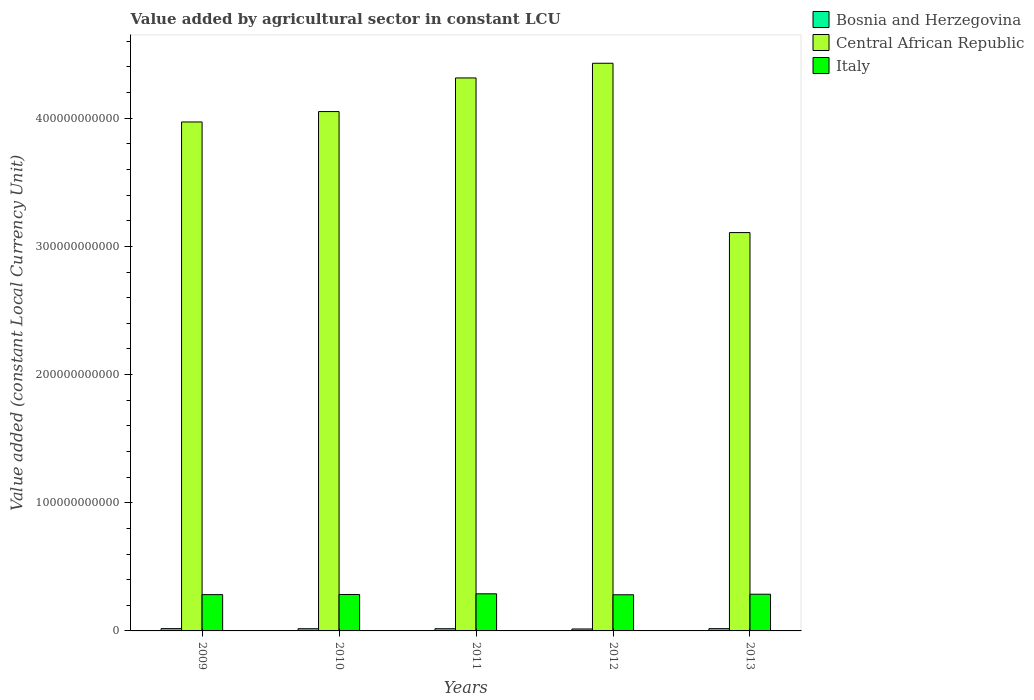How many groups of bars are there?
Your answer should be compact. 5. Are the number of bars per tick equal to the number of legend labels?
Your answer should be compact. Yes. Are the number of bars on each tick of the X-axis equal?
Provide a short and direct response. Yes. How many bars are there on the 5th tick from the left?
Provide a succinct answer. 3. What is the label of the 3rd group of bars from the left?
Your answer should be compact. 2011. What is the value added by agricultural sector in Bosnia and Herzegovina in 2011?
Offer a very short reply. 1.72e+09. Across all years, what is the maximum value added by agricultural sector in Bosnia and Herzegovina?
Your answer should be compact. 1.79e+09. Across all years, what is the minimum value added by agricultural sector in Italy?
Provide a succinct answer. 2.82e+1. In which year was the value added by agricultural sector in Italy minimum?
Ensure brevity in your answer.  2012. What is the total value added by agricultural sector in Italy in the graph?
Provide a succinct answer. 1.43e+11. What is the difference between the value added by agricultural sector in Central African Republic in 2009 and that in 2010?
Keep it short and to the point. -8.10e+09. What is the difference between the value added by agricultural sector in Bosnia and Herzegovina in 2009 and the value added by agricultural sector in Central African Republic in 2012?
Make the answer very short. -4.41e+11. What is the average value added by agricultural sector in Central African Republic per year?
Give a very brief answer. 3.97e+11. In the year 2013, what is the difference between the value added by agricultural sector in Italy and value added by agricultural sector in Central African Republic?
Make the answer very short. -2.82e+11. In how many years, is the value added by agricultural sector in Italy greater than 60000000000 LCU?
Your answer should be compact. 0. What is the ratio of the value added by agricultural sector in Central African Republic in 2009 to that in 2011?
Offer a very short reply. 0.92. Is the difference between the value added by agricultural sector in Italy in 2011 and 2013 greater than the difference between the value added by agricultural sector in Central African Republic in 2011 and 2013?
Provide a succinct answer. No. What is the difference between the highest and the second highest value added by agricultural sector in Italy?
Provide a short and direct response. 3.27e+08. What is the difference between the highest and the lowest value added by agricultural sector in Italy?
Make the answer very short. 7.50e+08. In how many years, is the value added by agricultural sector in Central African Republic greater than the average value added by agricultural sector in Central African Republic taken over all years?
Give a very brief answer. 3. Is the sum of the value added by agricultural sector in Bosnia and Herzegovina in 2009 and 2010 greater than the maximum value added by agricultural sector in Central African Republic across all years?
Keep it short and to the point. No. What does the 2nd bar from the left in 2011 represents?
Keep it short and to the point. Central African Republic. Is it the case that in every year, the sum of the value added by agricultural sector in Central African Republic and value added by agricultural sector in Bosnia and Herzegovina is greater than the value added by agricultural sector in Italy?
Provide a short and direct response. Yes. How many years are there in the graph?
Offer a very short reply. 5. What is the difference between two consecutive major ticks on the Y-axis?
Keep it short and to the point. 1.00e+11. Are the values on the major ticks of Y-axis written in scientific E-notation?
Keep it short and to the point. No. Does the graph contain any zero values?
Your response must be concise. No. Where does the legend appear in the graph?
Provide a succinct answer. Top right. How are the legend labels stacked?
Your answer should be very brief. Vertical. What is the title of the graph?
Keep it short and to the point. Value added by agricultural sector in constant LCU. What is the label or title of the X-axis?
Make the answer very short. Years. What is the label or title of the Y-axis?
Provide a short and direct response. Value added (constant Local Currency Unit). What is the Value added (constant Local Currency Unit) of Bosnia and Herzegovina in 2009?
Your response must be concise. 1.79e+09. What is the Value added (constant Local Currency Unit) in Central African Republic in 2009?
Provide a short and direct response. 3.97e+11. What is the Value added (constant Local Currency Unit) in Italy in 2009?
Give a very brief answer. 2.83e+1. What is the Value added (constant Local Currency Unit) in Bosnia and Herzegovina in 2010?
Your response must be concise. 1.72e+09. What is the Value added (constant Local Currency Unit) of Central African Republic in 2010?
Your answer should be compact. 4.05e+11. What is the Value added (constant Local Currency Unit) in Italy in 2010?
Ensure brevity in your answer.  2.84e+1. What is the Value added (constant Local Currency Unit) in Bosnia and Herzegovina in 2011?
Your answer should be very brief. 1.72e+09. What is the Value added (constant Local Currency Unit) of Central African Republic in 2011?
Make the answer very short. 4.31e+11. What is the Value added (constant Local Currency Unit) of Italy in 2011?
Give a very brief answer. 2.90e+1. What is the Value added (constant Local Currency Unit) in Bosnia and Herzegovina in 2012?
Offer a terse response. 1.52e+09. What is the Value added (constant Local Currency Unit) in Central African Republic in 2012?
Provide a short and direct response. 4.43e+11. What is the Value added (constant Local Currency Unit) of Italy in 2012?
Your answer should be compact. 2.82e+1. What is the Value added (constant Local Currency Unit) of Bosnia and Herzegovina in 2013?
Give a very brief answer. 1.76e+09. What is the Value added (constant Local Currency Unit) of Central African Republic in 2013?
Make the answer very short. 3.11e+11. What is the Value added (constant Local Currency Unit) in Italy in 2013?
Ensure brevity in your answer.  2.86e+1. Across all years, what is the maximum Value added (constant Local Currency Unit) of Bosnia and Herzegovina?
Ensure brevity in your answer.  1.79e+09. Across all years, what is the maximum Value added (constant Local Currency Unit) in Central African Republic?
Offer a terse response. 4.43e+11. Across all years, what is the maximum Value added (constant Local Currency Unit) in Italy?
Make the answer very short. 2.90e+1. Across all years, what is the minimum Value added (constant Local Currency Unit) of Bosnia and Herzegovina?
Make the answer very short. 1.52e+09. Across all years, what is the minimum Value added (constant Local Currency Unit) of Central African Republic?
Keep it short and to the point. 3.11e+11. Across all years, what is the minimum Value added (constant Local Currency Unit) in Italy?
Ensure brevity in your answer.  2.82e+1. What is the total Value added (constant Local Currency Unit) in Bosnia and Herzegovina in the graph?
Your response must be concise. 8.50e+09. What is the total Value added (constant Local Currency Unit) of Central African Republic in the graph?
Offer a terse response. 1.99e+12. What is the total Value added (constant Local Currency Unit) of Italy in the graph?
Offer a very short reply. 1.43e+11. What is the difference between the Value added (constant Local Currency Unit) in Bosnia and Herzegovina in 2009 and that in 2010?
Your response must be concise. 7.09e+07. What is the difference between the Value added (constant Local Currency Unit) of Central African Republic in 2009 and that in 2010?
Offer a very short reply. -8.10e+09. What is the difference between the Value added (constant Local Currency Unit) of Italy in 2009 and that in 2010?
Give a very brief answer. -1.03e+08. What is the difference between the Value added (constant Local Currency Unit) of Bosnia and Herzegovina in 2009 and that in 2011?
Offer a very short reply. 7.24e+07. What is the difference between the Value added (constant Local Currency Unit) of Central African Republic in 2009 and that in 2011?
Your answer should be compact. -3.43e+1. What is the difference between the Value added (constant Local Currency Unit) in Italy in 2009 and that in 2011?
Provide a short and direct response. -6.46e+08. What is the difference between the Value added (constant Local Currency Unit) in Bosnia and Herzegovina in 2009 and that in 2012?
Make the answer very short. 2.68e+08. What is the difference between the Value added (constant Local Currency Unit) of Central African Republic in 2009 and that in 2012?
Provide a succinct answer. -4.58e+1. What is the difference between the Value added (constant Local Currency Unit) in Italy in 2009 and that in 2012?
Ensure brevity in your answer.  1.04e+08. What is the difference between the Value added (constant Local Currency Unit) in Bosnia and Herzegovina in 2009 and that in 2013?
Give a very brief answer. 2.73e+07. What is the difference between the Value added (constant Local Currency Unit) in Central African Republic in 2009 and that in 2013?
Provide a short and direct response. 8.63e+1. What is the difference between the Value added (constant Local Currency Unit) in Italy in 2009 and that in 2013?
Keep it short and to the point. -3.19e+08. What is the difference between the Value added (constant Local Currency Unit) in Bosnia and Herzegovina in 2010 and that in 2011?
Your answer should be very brief. 1.49e+06. What is the difference between the Value added (constant Local Currency Unit) in Central African Republic in 2010 and that in 2011?
Provide a succinct answer. -2.62e+1. What is the difference between the Value added (constant Local Currency Unit) in Italy in 2010 and that in 2011?
Provide a succinct answer. -5.43e+08. What is the difference between the Value added (constant Local Currency Unit) in Bosnia and Herzegovina in 2010 and that in 2012?
Offer a terse response. 1.97e+08. What is the difference between the Value added (constant Local Currency Unit) of Central African Republic in 2010 and that in 2012?
Your answer should be compact. -3.77e+1. What is the difference between the Value added (constant Local Currency Unit) in Italy in 2010 and that in 2012?
Offer a terse response. 2.07e+08. What is the difference between the Value added (constant Local Currency Unit) of Bosnia and Herzegovina in 2010 and that in 2013?
Provide a succinct answer. -4.36e+07. What is the difference between the Value added (constant Local Currency Unit) of Central African Republic in 2010 and that in 2013?
Provide a succinct answer. 9.44e+1. What is the difference between the Value added (constant Local Currency Unit) in Italy in 2010 and that in 2013?
Offer a terse response. -2.16e+08. What is the difference between the Value added (constant Local Currency Unit) in Bosnia and Herzegovina in 2011 and that in 2012?
Offer a terse response. 1.95e+08. What is the difference between the Value added (constant Local Currency Unit) of Central African Republic in 2011 and that in 2012?
Your answer should be compact. -1.15e+1. What is the difference between the Value added (constant Local Currency Unit) in Italy in 2011 and that in 2012?
Provide a short and direct response. 7.50e+08. What is the difference between the Value added (constant Local Currency Unit) of Bosnia and Herzegovina in 2011 and that in 2013?
Your response must be concise. -4.51e+07. What is the difference between the Value added (constant Local Currency Unit) in Central African Republic in 2011 and that in 2013?
Give a very brief answer. 1.21e+11. What is the difference between the Value added (constant Local Currency Unit) of Italy in 2011 and that in 2013?
Provide a short and direct response. 3.27e+08. What is the difference between the Value added (constant Local Currency Unit) in Bosnia and Herzegovina in 2012 and that in 2013?
Your answer should be very brief. -2.40e+08. What is the difference between the Value added (constant Local Currency Unit) of Central African Republic in 2012 and that in 2013?
Offer a very short reply. 1.32e+11. What is the difference between the Value added (constant Local Currency Unit) of Italy in 2012 and that in 2013?
Offer a terse response. -4.23e+08. What is the difference between the Value added (constant Local Currency Unit) in Bosnia and Herzegovina in 2009 and the Value added (constant Local Currency Unit) in Central African Republic in 2010?
Ensure brevity in your answer.  -4.03e+11. What is the difference between the Value added (constant Local Currency Unit) of Bosnia and Herzegovina in 2009 and the Value added (constant Local Currency Unit) of Italy in 2010?
Keep it short and to the point. -2.66e+1. What is the difference between the Value added (constant Local Currency Unit) of Central African Republic in 2009 and the Value added (constant Local Currency Unit) of Italy in 2010?
Offer a very short reply. 3.69e+11. What is the difference between the Value added (constant Local Currency Unit) in Bosnia and Herzegovina in 2009 and the Value added (constant Local Currency Unit) in Central African Republic in 2011?
Provide a succinct answer. -4.30e+11. What is the difference between the Value added (constant Local Currency Unit) of Bosnia and Herzegovina in 2009 and the Value added (constant Local Currency Unit) of Italy in 2011?
Give a very brief answer. -2.72e+1. What is the difference between the Value added (constant Local Currency Unit) in Central African Republic in 2009 and the Value added (constant Local Currency Unit) in Italy in 2011?
Provide a short and direct response. 3.68e+11. What is the difference between the Value added (constant Local Currency Unit) in Bosnia and Herzegovina in 2009 and the Value added (constant Local Currency Unit) in Central African Republic in 2012?
Offer a terse response. -4.41e+11. What is the difference between the Value added (constant Local Currency Unit) of Bosnia and Herzegovina in 2009 and the Value added (constant Local Currency Unit) of Italy in 2012?
Keep it short and to the point. -2.64e+1. What is the difference between the Value added (constant Local Currency Unit) of Central African Republic in 2009 and the Value added (constant Local Currency Unit) of Italy in 2012?
Keep it short and to the point. 3.69e+11. What is the difference between the Value added (constant Local Currency Unit) of Bosnia and Herzegovina in 2009 and the Value added (constant Local Currency Unit) of Central African Republic in 2013?
Your answer should be compact. -3.09e+11. What is the difference between the Value added (constant Local Currency Unit) in Bosnia and Herzegovina in 2009 and the Value added (constant Local Currency Unit) in Italy in 2013?
Ensure brevity in your answer.  -2.68e+1. What is the difference between the Value added (constant Local Currency Unit) in Central African Republic in 2009 and the Value added (constant Local Currency Unit) in Italy in 2013?
Keep it short and to the point. 3.68e+11. What is the difference between the Value added (constant Local Currency Unit) of Bosnia and Herzegovina in 2010 and the Value added (constant Local Currency Unit) of Central African Republic in 2011?
Your answer should be compact. -4.30e+11. What is the difference between the Value added (constant Local Currency Unit) in Bosnia and Herzegovina in 2010 and the Value added (constant Local Currency Unit) in Italy in 2011?
Offer a very short reply. -2.72e+1. What is the difference between the Value added (constant Local Currency Unit) in Central African Republic in 2010 and the Value added (constant Local Currency Unit) in Italy in 2011?
Your answer should be very brief. 3.76e+11. What is the difference between the Value added (constant Local Currency Unit) in Bosnia and Herzegovina in 2010 and the Value added (constant Local Currency Unit) in Central African Republic in 2012?
Provide a succinct answer. -4.41e+11. What is the difference between the Value added (constant Local Currency Unit) of Bosnia and Herzegovina in 2010 and the Value added (constant Local Currency Unit) of Italy in 2012?
Keep it short and to the point. -2.65e+1. What is the difference between the Value added (constant Local Currency Unit) of Central African Republic in 2010 and the Value added (constant Local Currency Unit) of Italy in 2012?
Ensure brevity in your answer.  3.77e+11. What is the difference between the Value added (constant Local Currency Unit) of Bosnia and Herzegovina in 2010 and the Value added (constant Local Currency Unit) of Central African Republic in 2013?
Your answer should be compact. -3.09e+11. What is the difference between the Value added (constant Local Currency Unit) of Bosnia and Herzegovina in 2010 and the Value added (constant Local Currency Unit) of Italy in 2013?
Your answer should be very brief. -2.69e+1. What is the difference between the Value added (constant Local Currency Unit) in Central African Republic in 2010 and the Value added (constant Local Currency Unit) in Italy in 2013?
Provide a succinct answer. 3.77e+11. What is the difference between the Value added (constant Local Currency Unit) in Bosnia and Herzegovina in 2011 and the Value added (constant Local Currency Unit) in Central African Republic in 2012?
Offer a very short reply. -4.41e+11. What is the difference between the Value added (constant Local Currency Unit) of Bosnia and Herzegovina in 2011 and the Value added (constant Local Currency Unit) of Italy in 2012?
Make the answer very short. -2.65e+1. What is the difference between the Value added (constant Local Currency Unit) in Central African Republic in 2011 and the Value added (constant Local Currency Unit) in Italy in 2012?
Your response must be concise. 4.03e+11. What is the difference between the Value added (constant Local Currency Unit) in Bosnia and Herzegovina in 2011 and the Value added (constant Local Currency Unit) in Central African Republic in 2013?
Make the answer very short. -3.09e+11. What is the difference between the Value added (constant Local Currency Unit) in Bosnia and Herzegovina in 2011 and the Value added (constant Local Currency Unit) in Italy in 2013?
Your answer should be very brief. -2.69e+1. What is the difference between the Value added (constant Local Currency Unit) of Central African Republic in 2011 and the Value added (constant Local Currency Unit) of Italy in 2013?
Your response must be concise. 4.03e+11. What is the difference between the Value added (constant Local Currency Unit) of Bosnia and Herzegovina in 2012 and the Value added (constant Local Currency Unit) of Central African Republic in 2013?
Make the answer very short. -3.09e+11. What is the difference between the Value added (constant Local Currency Unit) of Bosnia and Herzegovina in 2012 and the Value added (constant Local Currency Unit) of Italy in 2013?
Ensure brevity in your answer.  -2.71e+1. What is the difference between the Value added (constant Local Currency Unit) of Central African Republic in 2012 and the Value added (constant Local Currency Unit) of Italy in 2013?
Offer a terse response. 4.14e+11. What is the average Value added (constant Local Currency Unit) in Bosnia and Herzegovina per year?
Provide a succinct answer. 1.70e+09. What is the average Value added (constant Local Currency Unit) in Central African Republic per year?
Your answer should be compact. 3.97e+11. What is the average Value added (constant Local Currency Unit) in Italy per year?
Your answer should be very brief. 2.85e+1. In the year 2009, what is the difference between the Value added (constant Local Currency Unit) of Bosnia and Herzegovina and Value added (constant Local Currency Unit) of Central African Republic?
Give a very brief answer. -3.95e+11. In the year 2009, what is the difference between the Value added (constant Local Currency Unit) in Bosnia and Herzegovina and Value added (constant Local Currency Unit) in Italy?
Give a very brief answer. -2.65e+1. In the year 2009, what is the difference between the Value added (constant Local Currency Unit) of Central African Republic and Value added (constant Local Currency Unit) of Italy?
Offer a terse response. 3.69e+11. In the year 2010, what is the difference between the Value added (constant Local Currency Unit) of Bosnia and Herzegovina and Value added (constant Local Currency Unit) of Central African Republic?
Keep it short and to the point. -4.03e+11. In the year 2010, what is the difference between the Value added (constant Local Currency Unit) of Bosnia and Herzegovina and Value added (constant Local Currency Unit) of Italy?
Offer a very short reply. -2.67e+1. In the year 2010, what is the difference between the Value added (constant Local Currency Unit) in Central African Republic and Value added (constant Local Currency Unit) in Italy?
Ensure brevity in your answer.  3.77e+11. In the year 2011, what is the difference between the Value added (constant Local Currency Unit) in Bosnia and Herzegovina and Value added (constant Local Currency Unit) in Central African Republic?
Give a very brief answer. -4.30e+11. In the year 2011, what is the difference between the Value added (constant Local Currency Unit) in Bosnia and Herzegovina and Value added (constant Local Currency Unit) in Italy?
Your answer should be very brief. -2.72e+1. In the year 2011, what is the difference between the Value added (constant Local Currency Unit) in Central African Republic and Value added (constant Local Currency Unit) in Italy?
Your answer should be very brief. 4.02e+11. In the year 2012, what is the difference between the Value added (constant Local Currency Unit) in Bosnia and Herzegovina and Value added (constant Local Currency Unit) in Central African Republic?
Your response must be concise. -4.41e+11. In the year 2012, what is the difference between the Value added (constant Local Currency Unit) in Bosnia and Herzegovina and Value added (constant Local Currency Unit) in Italy?
Keep it short and to the point. -2.67e+1. In the year 2012, what is the difference between the Value added (constant Local Currency Unit) in Central African Republic and Value added (constant Local Currency Unit) in Italy?
Provide a succinct answer. 4.15e+11. In the year 2013, what is the difference between the Value added (constant Local Currency Unit) of Bosnia and Herzegovina and Value added (constant Local Currency Unit) of Central African Republic?
Give a very brief answer. -3.09e+11. In the year 2013, what is the difference between the Value added (constant Local Currency Unit) in Bosnia and Herzegovina and Value added (constant Local Currency Unit) in Italy?
Keep it short and to the point. -2.69e+1. In the year 2013, what is the difference between the Value added (constant Local Currency Unit) in Central African Republic and Value added (constant Local Currency Unit) in Italy?
Your answer should be compact. 2.82e+11. What is the ratio of the Value added (constant Local Currency Unit) of Bosnia and Herzegovina in 2009 to that in 2010?
Your answer should be very brief. 1.04. What is the ratio of the Value added (constant Local Currency Unit) of Bosnia and Herzegovina in 2009 to that in 2011?
Offer a terse response. 1.04. What is the ratio of the Value added (constant Local Currency Unit) of Central African Republic in 2009 to that in 2011?
Make the answer very short. 0.92. What is the ratio of the Value added (constant Local Currency Unit) of Italy in 2009 to that in 2011?
Give a very brief answer. 0.98. What is the ratio of the Value added (constant Local Currency Unit) of Bosnia and Herzegovina in 2009 to that in 2012?
Your answer should be very brief. 1.18. What is the ratio of the Value added (constant Local Currency Unit) in Central African Republic in 2009 to that in 2012?
Your answer should be compact. 0.9. What is the ratio of the Value added (constant Local Currency Unit) of Italy in 2009 to that in 2012?
Provide a short and direct response. 1. What is the ratio of the Value added (constant Local Currency Unit) of Bosnia and Herzegovina in 2009 to that in 2013?
Provide a succinct answer. 1.02. What is the ratio of the Value added (constant Local Currency Unit) of Central African Republic in 2009 to that in 2013?
Offer a terse response. 1.28. What is the ratio of the Value added (constant Local Currency Unit) of Italy in 2009 to that in 2013?
Provide a short and direct response. 0.99. What is the ratio of the Value added (constant Local Currency Unit) of Central African Republic in 2010 to that in 2011?
Ensure brevity in your answer.  0.94. What is the ratio of the Value added (constant Local Currency Unit) in Italy in 2010 to that in 2011?
Offer a terse response. 0.98. What is the ratio of the Value added (constant Local Currency Unit) in Bosnia and Herzegovina in 2010 to that in 2012?
Provide a short and direct response. 1.13. What is the ratio of the Value added (constant Local Currency Unit) in Central African Republic in 2010 to that in 2012?
Provide a short and direct response. 0.91. What is the ratio of the Value added (constant Local Currency Unit) of Italy in 2010 to that in 2012?
Offer a very short reply. 1.01. What is the ratio of the Value added (constant Local Currency Unit) in Bosnia and Herzegovina in 2010 to that in 2013?
Provide a succinct answer. 0.98. What is the ratio of the Value added (constant Local Currency Unit) of Central African Republic in 2010 to that in 2013?
Offer a very short reply. 1.3. What is the ratio of the Value added (constant Local Currency Unit) in Italy in 2010 to that in 2013?
Your response must be concise. 0.99. What is the ratio of the Value added (constant Local Currency Unit) of Bosnia and Herzegovina in 2011 to that in 2012?
Your answer should be very brief. 1.13. What is the ratio of the Value added (constant Local Currency Unit) of Central African Republic in 2011 to that in 2012?
Offer a terse response. 0.97. What is the ratio of the Value added (constant Local Currency Unit) in Italy in 2011 to that in 2012?
Offer a very short reply. 1.03. What is the ratio of the Value added (constant Local Currency Unit) in Bosnia and Herzegovina in 2011 to that in 2013?
Keep it short and to the point. 0.97. What is the ratio of the Value added (constant Local Currency Unit) of Central African Republic in 2011 to that in 2013?
Your answer should be very brief. 1.39. What is the ratio of the Value added (constant Local Currency Unit) in Italy in 2011 to that in 2013?
Keep it short and to the point. 1.01. What is the ratio of the Value added (constant Local Currency Unit) of Bosnia and Herzegovina in 2012 to that in 2013?
Provide a succinct answer. 0.86. What is the ratio of the Value added (constant Local Currency Unit) in Central African Republic in 2012 to that in 2013?
Keep it short and to the point. 1.43. What is the ratio of the Value added (constant Local Currency Unit) in Italy in 2012 to that in 2013?
Your response must be concise. 0.99. What is the difference between the highest and the second highest Value added (constant Local Currency Unit) of Bosnia and Herzegovina?
Make the answer very short. 2.73e+07. What is the difference between the highest and the second highest Value added (constant Local Currency Unit) of Central African Republic?
Provide a short and direct response. 1.15e+1. What is the difference between the highest and the second highest Value added (constant Local Currency Unit) of Italy?
Provide a short and direct response. 3.27e+08. What is the difference between the highest and the lowest Value added (constant Local Currency Unit) in Bosnia and Herzegovina?
Make the answer very short. 2.68e+08. What is the difference between the highest and the lowest Value added (constant Local Currency Unit) in Central African Republic?
Ensure brevity in your answer.  1.32e+11. What is the difference between the highest and the lowest Value added (constant Local Currency Unit) in Italy?
Offer a very short reply. 7.50e+08. 